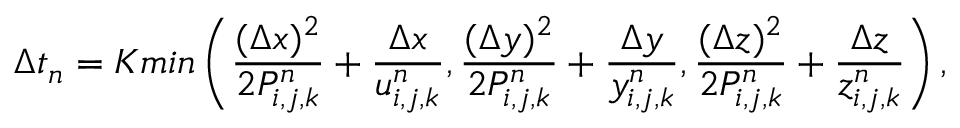<formula> <loc_0><loc_0><loc_500><loc_500>\Delta t _ { n } = K \min \left ( \frac { ( \Delta x ) ^ { 2 } } { 2 P _ { i , j , k } ^ { n } } + \frac { \Delta x } { u _ { i , j , k } ^ { n } } , \frac { ( \Delta y ) ^ { 2 } } { 2 P _ { i , j , k } ^ { n } } + \frac { \Delta y } { y _ { i , j , k } ^ { n } } , \frac { ( \Delta z ) ^ { 2 } } { 2 P _ { i , j , k } ^ { n } } + \frac { \Delta z } { z _ { i , j , k } ^ { n } } \right ) ,</formula> 